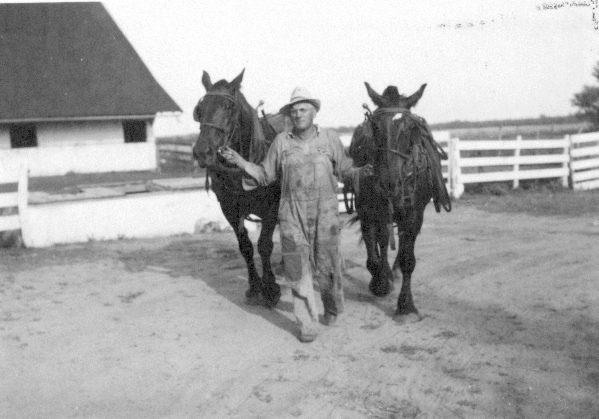<image>How cold is it? It is unknown how cold it is. How cold is it? I don't know how cold it is. It can be either not cold or 60 degrees. 